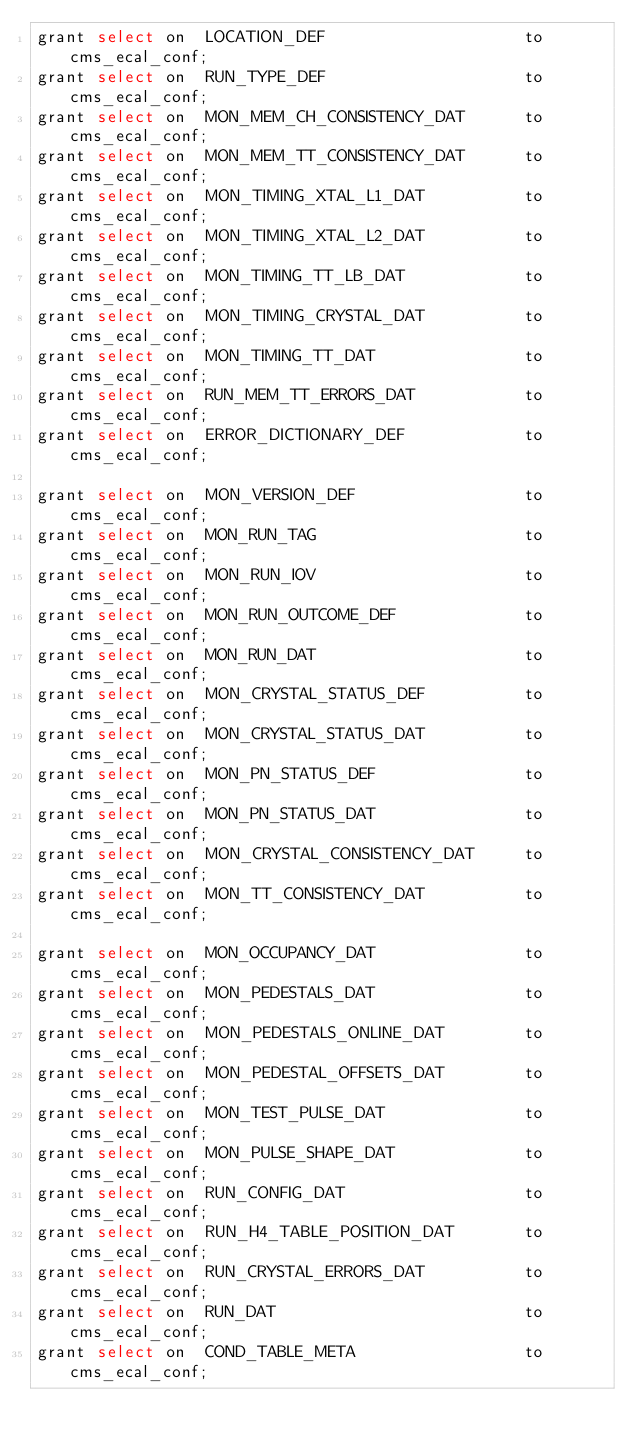Convert code to text. <code><loc_0><loc_0><loc_500><loc_500><_SQL_>grant select on  LOCATION_DEF                    to cms_ecal_conf;              
grant select on  RUN_TYPE_DEF                    to cms_ecal_conf;              
grant select on  MON_MEM_CH_CONSISTENCY_DAT      to cms_ecal_conf;              
grant select on  MON_MEM_TT_CONSISTENCY_DAT      to cms_ecal_conf;              
grant select on  MON_TIMING_XTAL_L1_DAT          to cms_ecal_conf;              
grant select on  MON_TIMING_XTAL_L2_DAT          to cms_ecal_conf;              
grant select on  MON_TIMING_TT_LB_DAT            to cms_ecal_conf;              
grant select on  MON_TIMING_CRYSTAL_DAT          to cms_ecal_conf;              
grant select on  MON_TIMING_TT_DAT               to cms_ecal_conf;              
grant select on  RUN_MEM_TT_ERRORS_DAT           to cms_ecal_conf;              
grant select on  ERROR_DICTIONARY_DEF            to cms_ecal_conf;              

grant select on  MON_VERSION_DEF                 to cms_ecal_conf;              
grant select on  MON_RUN_TAG                     to cms_ecal_conf;              
grant select on  MON_RUN_IOV                     to cms_ecal_conf;              
grant select on  MON_RUN_OUTCOME_DEF             to cms_ecal_conf;              
grant select on  MON_RUN_DAT                     to cms_ecal_conf;              
grant select on  MON_CRYSTAL_STATUS_DEF          to cms_ecal_conf;              
grant select on  MON_CRYSTAL_STATUS_DAT          to cms_ecal_conf;              
grant select on  MON_PN_STATUS_DEF               to cms_ecal_conf;              
grant select on  MON_PN_STATUS_DAT               to cms_ecal_conf;              
grant select on  MON_CRYSTAL_CONSISTENCY_DAT     to cms_ecal_conf;              
grant select on  MON_TT_CONSISTENCY_DAT          to cms_ecal_conf;              

grant select on  MON_OCCUPANCY_DAT               to cms_ecal_conf;              
grant select on  MON_PEDESTALS_DAT               to cms_ecal_conf;              
grant select on  MON_PEDESTALS_ONLINE_DAT        to cms_ecal_conf;              
grant select on  MON_PEDESTAL_OFFSETS_DAT        to cms_ecal_conf;              
grant select on  MON_TEST_PULSE_DAT              to cms_ecal_conf;              
grant select on  MON_PULSE_SHAPE_DAT             to cms_ecal_conf;              
grant select on  RUN_CONFIG_DAT                  to cms_ecal_conf;              
grant select on  RUN_H4_TABLE_POSITION_DAT       to cms_ecal_conf;              
grant select on  RUN_CRYSTAL_ERRORS_DAT          to cms_ecal_conf;              
grant select on  RUN_DAT                         to cms_ecal_conf;              
grant select on  COND_TABLE_META                 to cms_ecal_conf;              
</code> 